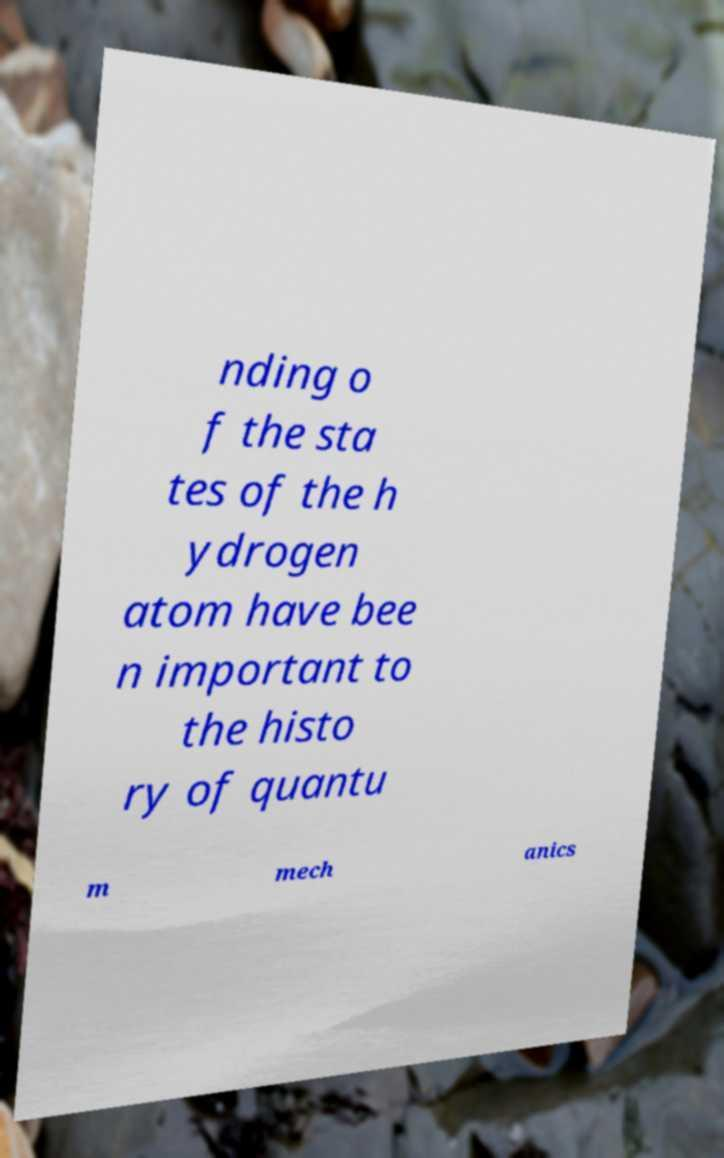Can you accurately transcribe the text from the provided image for me? nding o f the sta tes of the h ydrogen atom have bee n important to the histo ry of quantu m mech anics 